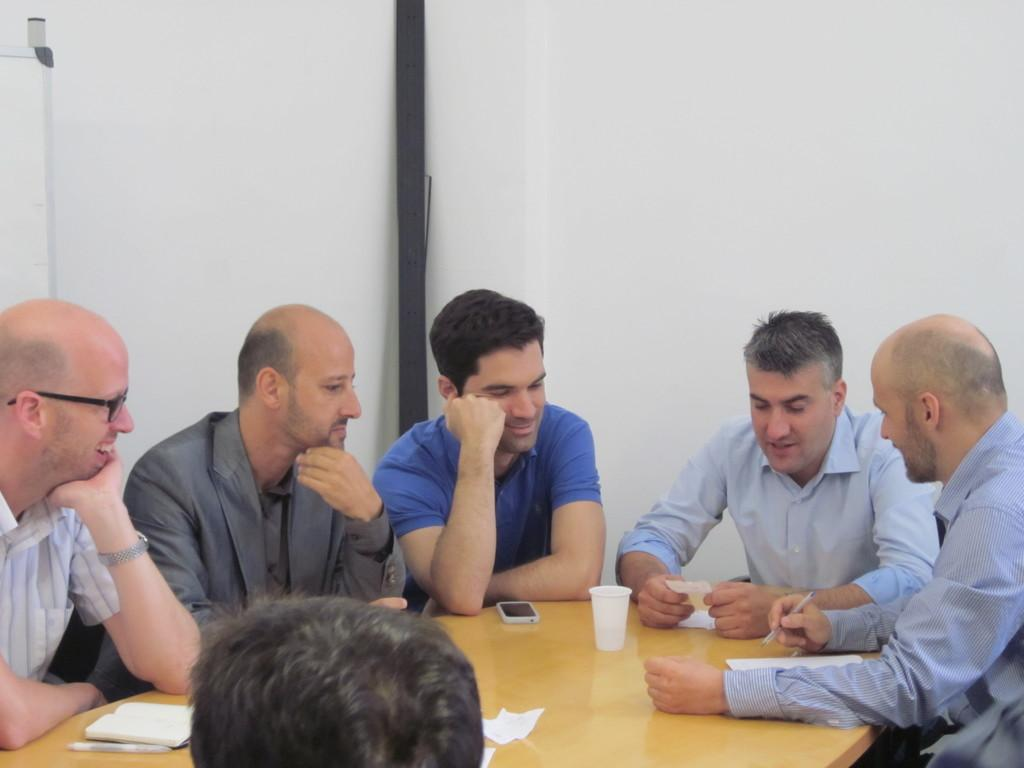How many people are in the image? There are 6 persons in the image. What are the persons doing in the image? The persons are sitting. What is in front of the persons? There is a table in front of the persons. What can be seen on the table? There are items on the table. What is visible in the background of the image? There is a wall in the background of the image. What type of twig is being used as a decoration on the table in the image? There is no twig present on the table in the image. What color is the copper pot on the table in the image? There is no copper pot present on the table in the image. 